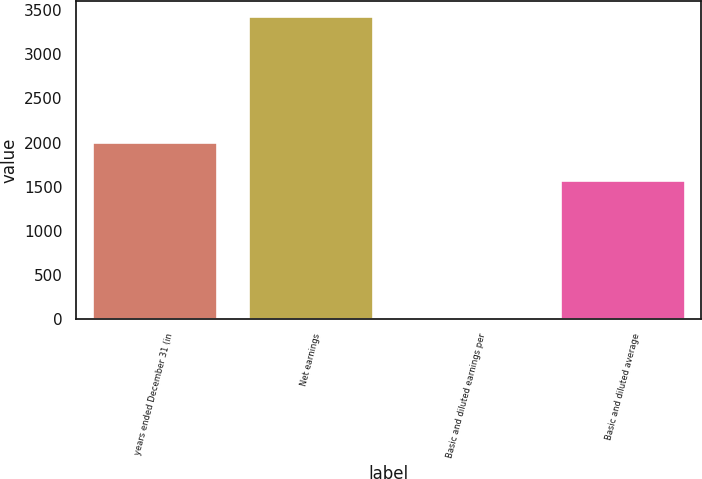Convert chart to OTSL. <chart><loc_0><loc_0><loc_500><loc_500><bar_chart><fcel>years ended December 31 (in<fcel>Net earnings<fcel>Basic and diluted earnings per<fcel>Basic and diluted average<nl><fcel>2011<fcel>3433<fcel>2.18<fcel>1577<nl></chart> 